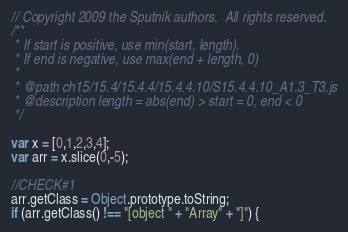Convert code to text. <code><loc_0><loc_0><loc_500><loc_500><_JavaScript_>// Copyright 2009 the Sputnik authors.  All rights reserved.
/**
 * If start is positive, use min(start, length).
 * If end is negative, use max(end + length, 0)
 *
 * @path ch15/15.4/15.4.4/15.4.4.10/S15.4.4.10_A1.3_T3.js
 * @description length = abs(end) > start = 0, end < 0
 */

var x = [0,1,2,3,4];
var arr = x.slice(0,-5);

//CHECK#1
arr.getClass = Object.prototype.toString;
if (arr.getClass() !== "[object " + "Array" + "]") {</code> 